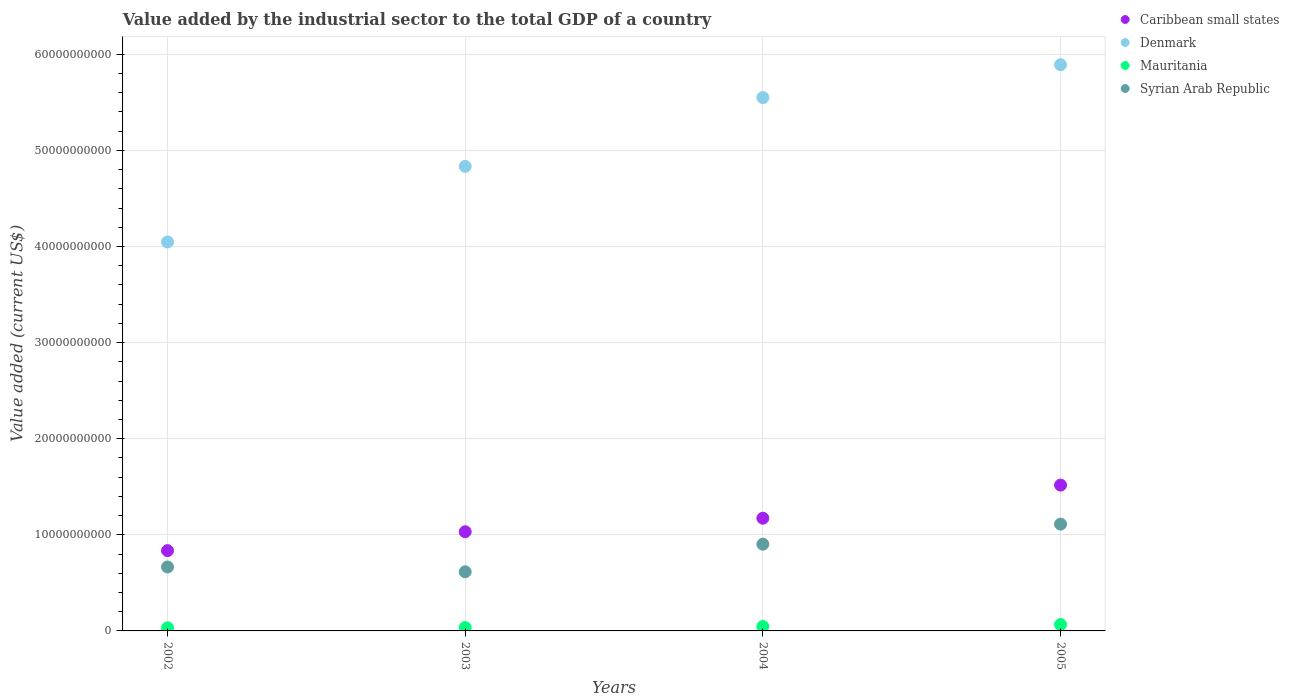What is the value added by the industrial sector to the total GDP in Denmark in 2003?
Give a very brief answer. 4.83e+1. Across all years, what is the maximum value added by the industrial sector to the total GDP in Denmark?
Make the answer very short. 5.89e+1. Across all years, what is the minimum value added by the industrial sector to the total GDP in Syrian Arab Republic?
Ensure brevity in your answer.  6.15e+09. What is the total value added by the industrial sector to the total GDP in Denmark in the graph?
Give a very brief answer. 2.03e+11. What is the difference between the value added by the industrial sector to the total GDP in Denmark in 2002 and that in 2005?
Your answer should be compact. -1.84e+1. What is the difference between the value added by the industrial sector to the total GDP in Denmark in 2004 and the value added by the industrial sector to the total GDP in Mauritania in 2002?
Make the answer very short. 5.52e+1. What is the average value added by the industrial sector to the total GDP in Denmark per year?
Your response must be concise. 5.08e+1. In the year 2002, what is the difference between the value added by the industrial sector to the total GDP in Denmark and value added by the industrial sector to the total GDP in Caribbean small states?
Ensure brevity in your answer.  3.21e+1. What is the ratio of the value added by the industrial sector to the total GDP in Denmark in 2002 to that in 2005?
Provide a short and direct response. 0.69. Is the difference between the value added by the industrial sector to the total GDP in Denmark in 2002 and 2004 greater than the difference between the value added by the industrial sector to the total GDP in Caribbean small states in 2002 and 2004?
Give a very brief answer. No. What is the difference between the highest and the second highest value added by the industrial sector to the total GDP in Mauritania?
Provide a succinct answer. 2.09e+08. What is the difference between the highest and the lowest value added by the industrial sector to the total GDP in Denmark?
Give a very brief answer. 1.84e+1. In how many years, is the value added by the industrial sector to the total GDP in Denmark greater than the average value added by the industrial sector to the total GDP in Denmark taken over all years?
Make the answer very short. 2. Is the sum of the value added by the industrial sector to the total GDP in Caribbean small states in 2002 and 2005 greater than the maximum value added by the industrial sector to the total GDP in Mauritania across all years?
Ensure brevity in your answer.  Yes. Is it the case that in every year, the sum of the value added by the industrial sector to the total GDP in Caribbean small states and value added by the industrial sector to the total GDP in Mauritania  is greater than the sum of value added by the industrial sector to the total GDP in Denmark and value added by the industrial sector to the total GDP in Syrian Arab Republic?
Your response must be concise. No. Is the value added by the industrial sector to the total GDP in Mauritania strictly greater than the value added by the industrial sector to the total GDP in Denmark over the years?
Provide a short and direct response. No. Is the value added by the industrial sector to the total GDP in Caribbean small states strictly less than the value added by the industrial sector to the total GDP in Syrian Arab Republic over the years?
Keep it short and to the point. No. Are the values on the major ticks of Y-axis written in scientific E-notation?
Offer a terse response. No. Does the graph contain any zero values?
Provide a succinct answer. No. Does the graph contain grids?
Your response must be concise. Yes. How many legend labels are there?
Your answer should be very brief. 4. How are the legend labels stacked?
Provide a short and direct response. Vertical. What is the title of the graph?
Provide a short and direct response. Value added by the industrial sector to the total GDP of a country. What is the label or title of the X-axis?
Your response must be concise. Years. What is the label or title of the Y-axis?
Offer a terse response. Value added (current US$). What is the Value added (current US$) in Caribbean small states in 2002?
Your answer should be very brief. 8.35e+09. What is the Value added (current US$) of Denmark in 2002?
Your answer should be compact. 4.05e+1. What is the Value added (current US$) of Mauritania in 2002?
Ensure brevity in your answer.  3.25e+08. What is the Value added (current US$) in Syrian Arab Republic in 2002?
Keep it short and to the point. 6.65e+09. What is the Value added (current US$) of Caribbean small states in 2003?
Your answer should be compact. 1.03e+1. What is the Value added (current US$) of Denmark in 2003?
Offer a very short reply. 4.83e+1. What is the Value added (current US$) in Mauritania in 2003?
Your answer should be very brief. 3.52e+08. What is the Value added (current US$) of Syrian Arab Republic in 2003?
Your answer should be very brief. 6.15e+09. What is the Value added (current US$) in Caribbean small states in 2004?
Give a very brief answer. 1.17e+1. What is the Value added (current US$) of Denmark in 2004?
Your answer should be very brief. 5.55e+1. What is the Value added (current US$) in Mauritania in 2004?
Offer a very short reply. 4.60e+08. What is the Value added (current US$) of Syrian Arab Republic in 2004?
Give a very brief answer. 9.02e+09. What is the Value added (current US$) in Caribbean small states in 2005?
Your answer should be very brief. 1.52e+1. What is the Value added (current US$) in Denmark in 2005?
Offer a very short reply. 5.89e+1. What is the Value added (current US$) of Mauritania in 2005?
Ensure brevity in your answer.  6.69e+08. What is the Value added (current US$) of Syrian Arab Republic in 2005?
Your answer should be very brief. 1.11e+1. Across all years, what is the maximum Value added (current US$) in Caribbean small states?
Your answer should be compact. 1.52e+1. Across all years, what is the maximum Value added (current US$) in Denmark?
Give a very brief answer. 5.89e+1. Across all years, what is the maximum Value added (current US$) in Mauritania?
Ensure brevity in your answer.  6.69e+08. Across all years, what is the maximum Value added (current US$) in Syrian Arab Republic?
Your response must be concise. 1.11e+1. Across all years, what is the minimum Value added (current US$) of Caribbean small states?
Offer a terse response. 8.35e+09. Across all years, what is the minimum Value added (current US$) in Denmark?
Offer a terse response. 4.05e+1. Across all years, what is the minimum Value added (current US$) of Mauritania?
Keep it short and to the point. 3.25e+08. Across all years, what is the minimum Value added (current US$) of Syrian Arab Republic?
Make the answer very short. 6.15e+09. What is the total Value added (current US$) of Caribbean small states in the graph?
Provide a succinct answer. 4.56e+1. What is the total Value added (current US$) of Denmark in the graph?
Your response must be concise. 2.03e+11. What is the total Value added (current US$) of Mauritania in the graph?
Ensure brevity in your answer.  1.81e+09. What is the total Value added (current US$) of Syrian Arab Republic in the graph?
Your response must be concise. 3.29e+1. What is the difference between the Value added (current US$) in Caribbean small states in 2002 and that in 2003?
Your answer should be very brief. -1.97e+09. What is the difference between the Value added (current US$) in Denmark in 2002 and that in 2003?
Your response must be concise. -7.87e+09. What is the difference between the Value added (current US$) of Mauritania in 2002 and that in 2003?
Keep it short and to the point. -2.76e+07. What is the difference between the Value added (current US$) of Syrian Arab Republic in 2002 and that in 2003?
Offer a very short reply. 5.00e+08. What is the difference between the Value added (current US$) in Caribbean small states in 2002 and that in 2004?
Your answer should be very brief. -3.37e+09. What is the difference between the Value added (current US$) of Denmark in 2002 and that in 2004?
Your answer should be very brief. -1.50e+1. What is the difference between the Value added (current US$) in Mauritania in 2002 and that in 2004?
Keep it short and to the point. -1.35e+08. What is the difference between the Value added (current US$) in Syrian Arab Republic in 2002 and that in 2004?
Offer a terse response. -2.37e+09. What is the difference between the Value added (current US$) of Caribbean small states in 2002 and that in 2005?
Offer a terse response. -6.82e+09. What is the difference between the Value added (current US$) of Denmark in 2002 and that in 2005?
Your answer should be compact. -1.84e+1. What is the difference between the Value added (current US$) of Mauritania in 2002 and that in 2005?
Ensure brevity in your answer.  -3.45e+08. What is the difference between the Value added (current US$) of Syrian Arab Republic in 2002 and that in 2005?
Give a very brief answer. -4.46e+09. What is the difference between the Value added (current US$) in Caribbean small states in 2003 and that in 2004?
Provide a succinct answer. -1.41e+09. What is the difference between the Value added (current US$) in Denmark in 2003 and that in 2004?
Make the answer very short. -7.16e+09. What is the difference between the Value added (current US$) in Mauritania in 2003 and that in 2004?
Make the answer very short. -1.08e+08. What is the difference between the Value added (current US$) in Syrian Arab Republic in 2003 and that in 2004?
Make the answer very short. -2.87e+09. What is the difference between the Value added (current US$) in Caribbean small states in 2003 and that in 2005?
Your answer should be compact. -4.85e+09. What is the difference between the Value added (current US$) in Denmark in 2003 and that in 2005?
Offer a terse response. -1.06e+1. What is the difference between the Value added (current US$) of Mauritania in 2003 and that in 2005?
Your answer should be very brief. -3.17e+08. What is the difference between the Value added (current US$) of Syrian Arab Republic in 2003 and that in 2005?
Your answer should be very brief. -4.96e+09. What is the difference between the Value added (current US$) of Caribbean small states in 2004 and that in 2005?
Ensure brevity in your answer.  -3.45e+09. What is the difference between the Value added (current US$) of Denmark in 2004 and that in 2005?
Provide a succinct answer. -3.41e+09. What is the difference between the Value added (current US$) of Mauritania in 2004 and that in 2005?
Your answer should be very brief. -2.09e+08. What is the difference between the Value added (current US$) in Syrian Arab Republic in 2004 and that in 2005?
Keep it short and to the point. -2.09e+09. What is the difference between the Value added (current US$) of Caribbean small states in 2002 and the Value added (current US$) of Denmark in 2003?
Your answer should be very brief. -4.00e+1. What is the difference between the Value added (current US$) of Caribbean small states in 2002 and the Value added (current US$) of Mauritania in 2003?
Provide a succinct answer. 8.00e+09. What is the difference between the Value added (current US$) in Caribbean small states in 2002 and the Value added (current US$) in Syrian Arab Republic in 2003?
Your answer should be very brief. 2.20e+09. What is the difference between the Value added (current US$) in Denmark in 2002 and the Value added (current US$) in Mauritania in 2003?
Provide a succinct answer. 4.01e+1. What is the difference between the Value added (current US$) of Denmark in 2002 and the Value added (current US$) of Syrian Arab Republic in 2003?
Your answer should be very brief. 3.43e+1. What is the difference between the Value added (current US$) of Mauritania in 2002 and the Value added (current US$) of Syrian Arab Republic in 2003?
Make the answer very short. -5.83e+09. What is the difference between the Value added (current US$) of Caribbean small states in 2002 and the Value added (current US$) of Denmark in 2004?
Your answer should be compact. -4.71e+1. What is the difference between the Value added (current US$) in Caribbean small states in 2002 and the Value added (current US$) in Mauritania in 2004?
Offer a terse response. 7.89e+09. What is the difference between the Value added (current US$) of Caribbean small states in 2002 and the Value added (current US$) of Syrian Arab Republic in 2004?
Offer a terse response. -6.70e+08. What is the difference between the Value added (current US$) of Denmark in 2002 and the Value added (current US$) of Mauritania in 2004?
Offer a very short reply. 4.00e+1. What is the difference between the Value added (current US$) in Denmark in 2002 and the Value added (current US$) in Syrian Arab Republic in 2004?
Provide a short and direct response. 3.14e+1. What is the difference between the Value added (current US$) in Mauritania in 2002 and the Value added (current US$) in Syrian Arab Republic in 2004?
Keep it short and to the point. -8.70e+09. What is the difference between the Value added (current US$) in Caribbean small states in 2002 and the Value added (current US$) in Denmark in 2005?
Your answer should be compact. -5.06e+1. What is the difference between the Value added (current US$) in Caribbean small states in 2002 and the Value added (current US$) in Mauritania in 2005?
Offer a very short reply. 7.68e+09. What is the difference between the Value added (current US$) in Caribbean small states in 2002 and the Value added (current US$) in Syrian Arab Republic in 2005?
Offer a terse response. -2.76e+09. What is the difference between the Value added (current US$) in Denmark in 2002 and the Value added (current US$) in Mauritania in 2005?
Your answer should be very brief. 3.98e+1. What is the difference between the Value added (current US$) in Denmark in 2002 and the Value added (current US$) in Syrian Arab Republic in 2005?
Provide a short and direct response. 2.94e+1. What is the difference between the Value added (current US$) of Mauritania in 2002 and the Value added (current US$) of Syrian Arab Republic in 2005?
Your answer should be very brief. -1.08e+1. What is the difference between the Value added (current US$) of Caribbean small states in 2003 and the Value added (current US$) of Denmark in 2004?
Give a very brief answer. -4.52e+1. What is the difference between the Value added (current US$) of Caribbean small states in 2003 and the Value added (current US$) of Mauritania in 2004?
Give a very brief answer. 9.86e+09. What is the difference between the Value added (current US$) of Caribbean small states in 2003 and the Value added (current US$) of Syrian Arab Republic in 2004?
Provide a short and direct response. 1.30e+09. What is the difference between the Value added (current US$) of Denmark in 2003 and the Value added (current US$) of Mauritania in 2004?
Your response must be concise. 4.79e+1. What is the difference between the Value added (current US$) in Denmark in 2003 and the Value added (current US$) in Syrian Arab Republic in 2004?
Give a very brief answer. 3.93e+1. What is the difference between the Value added (current US$) of Mauritania in 2003 and the Value added (current US$) of Syrian Arab Republic in 2004?
Keep it short and to the point. -8.67e+09. What is the difference between the Value added (current US$) of Caribbean small states in 2003 and the Value added (current US$) of Denmark in 2005?
Provide a succinct answer. -4.86e+1. What is the difference between the Value added (current US$) of Caribbean small states in 2003 and the Value added (current US$) of Mauritania in 2005?
Keep it short and to the point. 9.65e+09. What is the difference between the Value added (current US$) in Caribbean small states in 2003 and the Value added (current US$) in Syrian Arab Republic in 2005?
Provide a short and direct response. -7.91e+08. What is the difference between the Value added (current US$) in Denmark in 2003 and the Value added (current US$) in Mauritania in 2005?
Your answer should be very brief. 4.77e+1. What is the difference between the Value added (current US$) in Denmark in 2003 and the Value added (current US$) in Syrian Arab Republic in 2005?
Offer a terse response. 3.72e+1. What is the difference between the Value added (current US$) of Mauritania in 2003 and the Value added (current US$) of Syrian Arab Republic in 2005?
Your response must be concise. -1.08e+1. What is the difference between the Value added (current US$) of Caribbean small states in 2004 and the Value added (current US$) of Denmark in 2005?
Your answer should be very brief. -4.72e+1. What is the difference between the Value added (current US$) of Caribbean small states in 2004 and the Value added (current US$) of Mauritania in 2005?
Your answer should be very brief. 1.11e+1. What is the difference between the Value added (current US$) of Caribbean small states in 2004 and the Value added (current US$) of Syrian Arab Republic in 2005?
Your answer should be compact. 6.17e+08. What is the difference between the Value added (current US$) in Denmark in 2004 and the Value added (current US$) in Mauritania in 2005?
Give a very brief answer. 5.48e+1. What is the difference between the Value added (current US$) of Denmark in 2004 and the Value added (current US$) of Syrian Arab Republic in 2005?
Your answer should be very brief. 4.44e+1. What is the difference between the Value added (current US$) in Mauritania in 2004 and the Value added (current US$) in Syrian Arab Republic in 2005?
Your answer should be compact. -1.07e+1. What is the average Value added (current US$) of Caribbean small states per year?
Offer a terse response. 1.14e+1. What is the average Value added (current US$) in Denmark per year?
Offer a very short reply. 5.08e+1. What is the average Value added (current US$) of Mauritania per year?
Your answer should be very brief. 4.51e+08. What is the average Value added (current US$) of Syrian Arab Republic per year?
Provide a short and direct response. 8.24e+09. In the year 2002, what is the difference between the Value added (current US$) in Caribbean small states and Value added (current US$) in Denmark?
Offer a very short reply. -3.21e+1. In the year 2002, what is the difference between the Value added (current US$) in Caribbean small states and Value added (current US$) in Mauritania?
Your response must be concise. 8.03e+09. In the year 2002, what is the difference between the Value added (current US$) of Caribbean small states and Value added (current US$) of Syrian Arab Republic?
Offer a terse response. 1.70e+09. In the year 2002, what is the difference between the Value added (current US$) of Denmark and Value added (current US$) of Mauritania?
Your answer should be very brief. 4.01e+1. In the year 2002, what is the difference between the Value added (current US$) in Denmark and Value added (current US$) in Syrian Arab Republic?
Ensure brevity in your answer.  3.38e+1. In the year 2002, what is the difference between the Value added (current US$) of Mauritania and Value added (current US$) of Syrian Arab Republic?
Give a very brief answer. -6.33e+09. In the year 2003, what is the difference between the Value added (current US$) of Caribbean small states and Value added (current US$) of Denmark?
Your response must be concise. -3.80e+1. In the year 2003, what is the difference between the Value added (current US$) in Caribbean small states and Value added (current US$) in Mauritania?
Keep it short and to the point. 9.97e+09. In the year 2003, what is the difference between the Value added (current US$) in Caribbean small states and Value added (current US$) in Syrian Arab Republic?
Give a very brief answer. 4.17e+09. In the year 2003, what is the difference between the Value added (current US$) in Denmark and Value added (current US$) in Mauritania?
Your answer should be compact. 4.80e+1. In the year 2003, what is the difference between the Value added (current US$) in Denmark and Value added (current US$) in Syrian Arab Republic?
Ensure brevity in your answer.  4.22e+1. In the year 2003, what is the difference between the Value added (current US$) in Mauritania and Value added (current US$) in Syrian Arab Republic?
Keep it short and to the point. -5.80e+09. In the year 2004, what is the difference between the Value added (current US$) of Caribbean small states and Value added (current US$) of Denmark?
Your answer should be very brief. -4.38e+1. In the year 2004, what is the difference between the Value added (current US$) in Caribbean small states and Value added (current US$) in Mauritania?
Make the answer very short. 1.13e+1. In the year 2004, what is the difference between the Value added (current US$) of Caribbean small states and Value added (current US$) of Syrian Arab Republic?
Offer a very short reply. 2.70e+09. In the year 2004, what is the difference between the Value added (current US$) in Denmark and Value added (current US$) in Mauritania?
Your answer should be compact. 5.50e+1. In the year 2004, what is the difference between the Value added (current US$) of Denmark and Value added (current US$) of Syrian Arab Republic?
Provide a short and direct response. 4.65e+1. In the year 2004, what is the difference between the Value added (current US$) of Mauritania and Value added (current US$) of Syrian Arab Republic?
Make the answer very short. -8.56e+09. In the year 2005, what is the difference between the Value added (current US$) of Caribbean small states and Value added (current US$) of Denmark?
Provide a short and direct response. -4.37e+1. In the year 2005, what is the difference between the Value added (current US$) of Caribbean small states and Value added (current US$) of Mauritania?
Give a very brief answer. 1.45e+1. In the year 2005, what is the difference between the Value added (current US$) in Caribbean small states and Value added (current US$) in Syrian Arab Republic?
Your response must be concise. 4.06e+09. In the year 2005, what is the difference between the Value added (current US$) of Denmark and Value added (current US$) of Mauritania?
Ensure brevity in your answer.  5.82e+1. In the year 2005, what is the difference between the Value added (current US$) in Denmark and Value added (current US$) in Syrian Arab Republic?
Ensure brevity in your answer.  4.78e+1. In the year 2005, what is the difference between the Value added (current US$) in Mauritania and Value added (current US$) in Syrian Arab Republic?
Offer a terse response. -1.04e+1. What is the ratio of the Value added (current US$) in Caribbean small states in 2002 to that in 2003?
Provide a succinct answer. 0.81. What is the ratio of the Value added (current US$) of Denmark in 2002 to that in 2003?
Your answer should be very brief. 0.84. What is the ratio of the Value added (current US$) in Mauritania in 2002 to that in 2003?
Keep it short and to the point. 0.92. What is the ratio of the Value added (current US$) of Syrian Arab Republic in 2002 to that in 2003?
Offer a very short reply. 1.08. What is the ratio of the Value added (current US$) of Caribbean small states in 2002 to that in 2004?
Your answer should be compact. 0.71. What is the ratio of the Value added (current US$) in Denmark in 2002 to that in 2004?
Offer a terse response. 0.73. What is the ratio of the Value added (current US$) in Mauritania in 2002 to that in 2004?
Ensure brevity in your answer.  0.71. What is the ratio of the Value added (current US$) of Syrian Arab Republic in 2002 to that in 2004?
Make the answer very short. 0.74. What is the ratio of the Value added (current US$) in Caribbean small states in 2002 to that in 2005?
Your response must be concise. 0.55. What is the ratio of the Value added (current US$) of Denmark in 2002 to that in 2005?
Keep it short and to the point. 0.69. What is the ratio of the Value added (current US$) of Mauritania in 2002 to that in 2005?
Your answer should be compact. 0.49. What is the ratio of the Value added (current US$) of Syrian Arab Republic in 2002 to that in 2005?
Provide a succinct answer. 0.6. What is the ratio of the Value added (current US$) of Denmark in 2003 to that in 2004?
Provide a short and direct response. 0.87. What is the ratio of the Value added (current US$) of Mauritania in 2003 to that in 2004?
Your answer should be compact. 0.77. What is the ratio of the Value added (current US$) in Syrian Arab Republic in 2003 to that in 2004?
Make the answer very short. 0.68. What is the ratio of the Value added (current US$) in Caribbean small states in 2003 to that in 2005?
Give a very brief answer. 0.68. What is the ratio of the Value added (current US$) in Denmark in 2003 to that in 2005?
Offer a terse response. 0.82. What is the ratio of the Value added (current US$) of Mauritania in 2003 to that in 2005?
Ensure brevity in your answer.  0.53. What is the ratio of the Value added (current US$) of Syrian Arab Republic in 2003 to that in 2005?
Ensure brevity in your answer.  0.55. What is the ratio of the Value added (current US$) in Caribbean small states in 2004 to that in 2005?
Offer a very short reply. 0.77. What is the ratio of the Value added (current US$) in Denmark in 2004 to that in 2005?
Give a very brief answer. 0.94. What is the ratio of the Value added (current US$) in Mauritania in 2004 to that in 2005?
Your response must be concise. 0.69. What is the ratio of the Value added (current US$) of Syrian Arab Republic in 2004 to that in 2005?
Provide a succinct answer. 0.81. What is the difference between the highest and the second highest Value added (current US$) of Caribbean small states?
Provide a succinct answer. 3.45e+09. What is the difference between the highest and the second highest Value added (current US$) in Denmark?
Ensure brevity in your answer.  3.41e+09. What is the difference between the highest and the second highest Value added (current US$) of Mauritania?
Your answer should be very brief. 2.09e+08. What is the difference between the highest and the second highest Value added (current US$) of Syrian Arab Republic?
Keep it short and to the point. 2.09e+09. What is the difference between the highest and the lowest Value added (current US$) in Caribbean small states?
Make the answer very short. 6.82e+09. What is the difference between the highest and the lowest Value added (current US$) in Denmark?
Your answer should be compact. 1.84e+1. What is the difference between the highest and the lowest Value added (current US$) in Mauritania?
Offer a terse response. 3.45e+08. What is the difference between the highest and the lowest Value added (current US$) of Syrian Arab Republic?
Keep it short and to the point. 4.96e+09. 